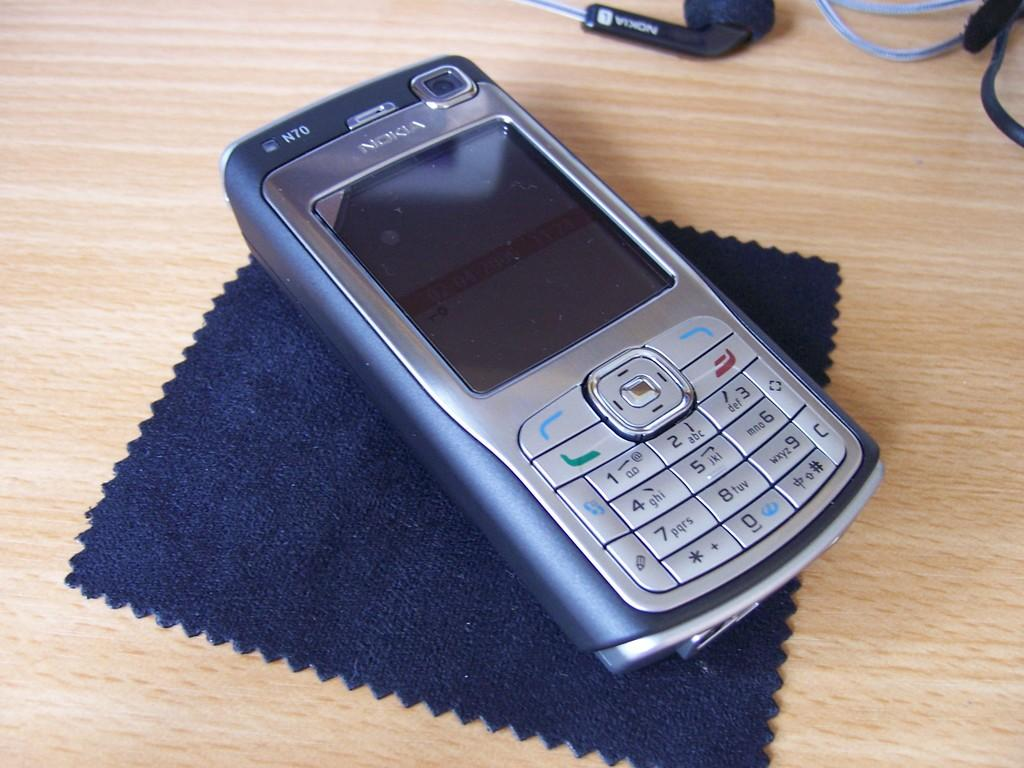<image>
Provide a brief description of the given image. A Nokia N70 mobile phone sitting on a desk. 